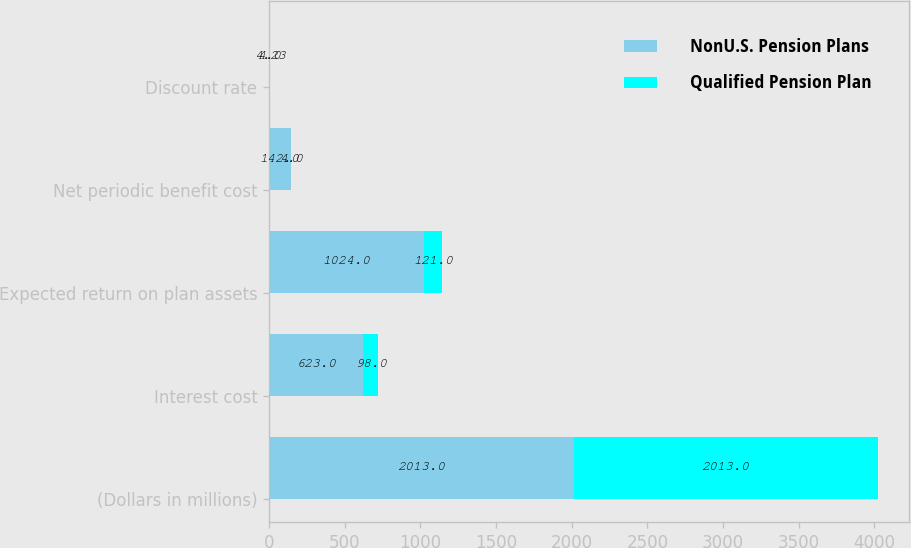<chart> <loc_0><loc_0><loc_500><loc_500><stacked_bar_chart><ecel><fcel>(Dollars in millions)<fcel>Interest cost<fcel>Expected return on plan assets<fcel>Net periodic benefit cost<fcel>Discount rate<nl><fcel>NonU.S. Pension Plans<fcel>2013<fcel>623<fcel>1024<fcel>142<fcel>4<nl><fcel>Qualified Pension Plan<fcel>2013<fcel>98<fcel>121<fcel>4<fcel>4.23<nl></chart> 